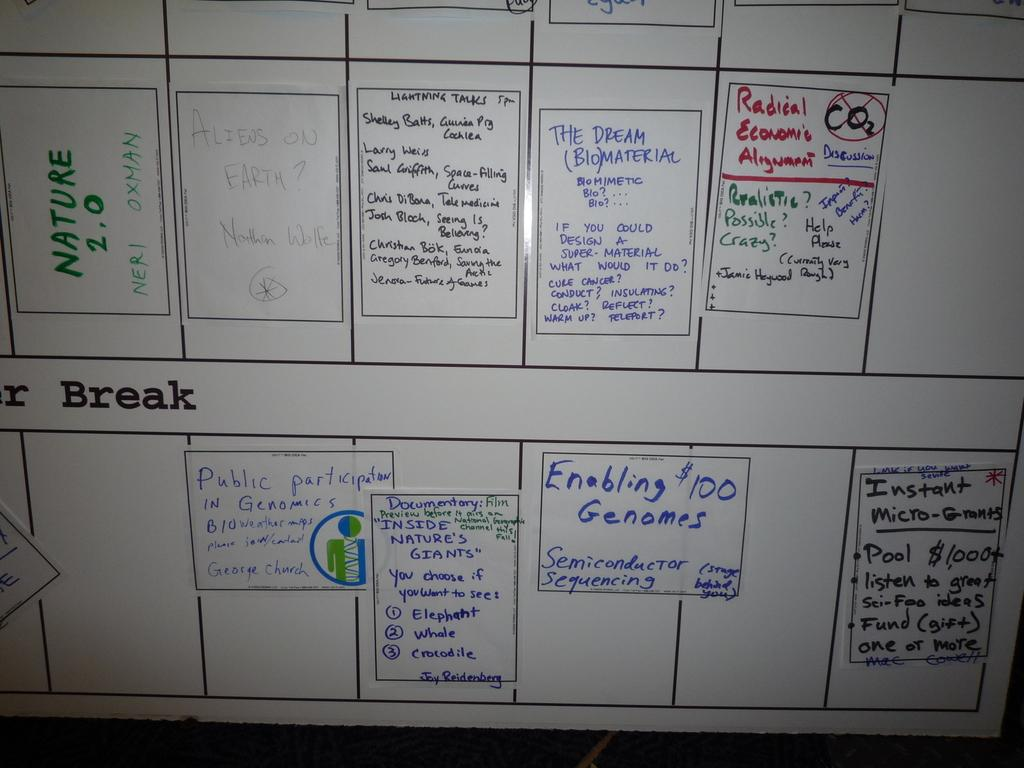<image>
Provide a brief description of the given image. A large whiteboard reveals plan for summer break. 